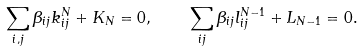<formula> <loc_0><loc_0><loc_500><loc_500>\sum _ { i , j } \beta _ { i j } k _ { i j } ^ { N } + K _ { N } = 0 , \quad \sum _ { i j } \beta _ { i j } l _ { i j } ^ { N - 1 } + L _ { N - 1 } = 0 .</formula> 